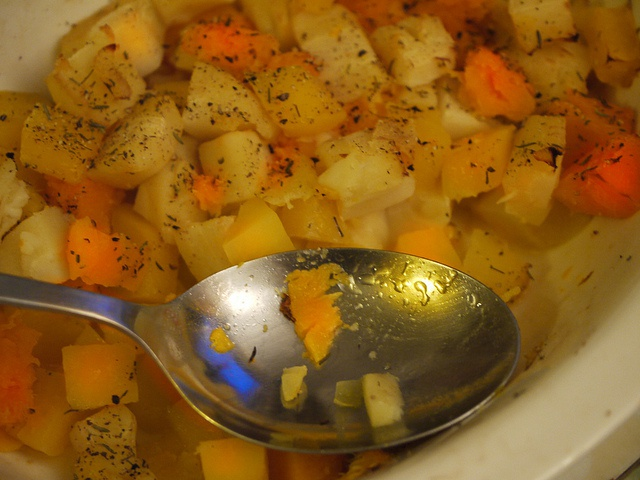Describe the objects in this image and their specific colors. I can see spoon in olive and black tones, bowl in olive and tan tones, carrot in olive, maroon, and red tones, carrot in olive, brown, red, and maroon tones, and carrot in olive, red, and maroon tones in this image. 